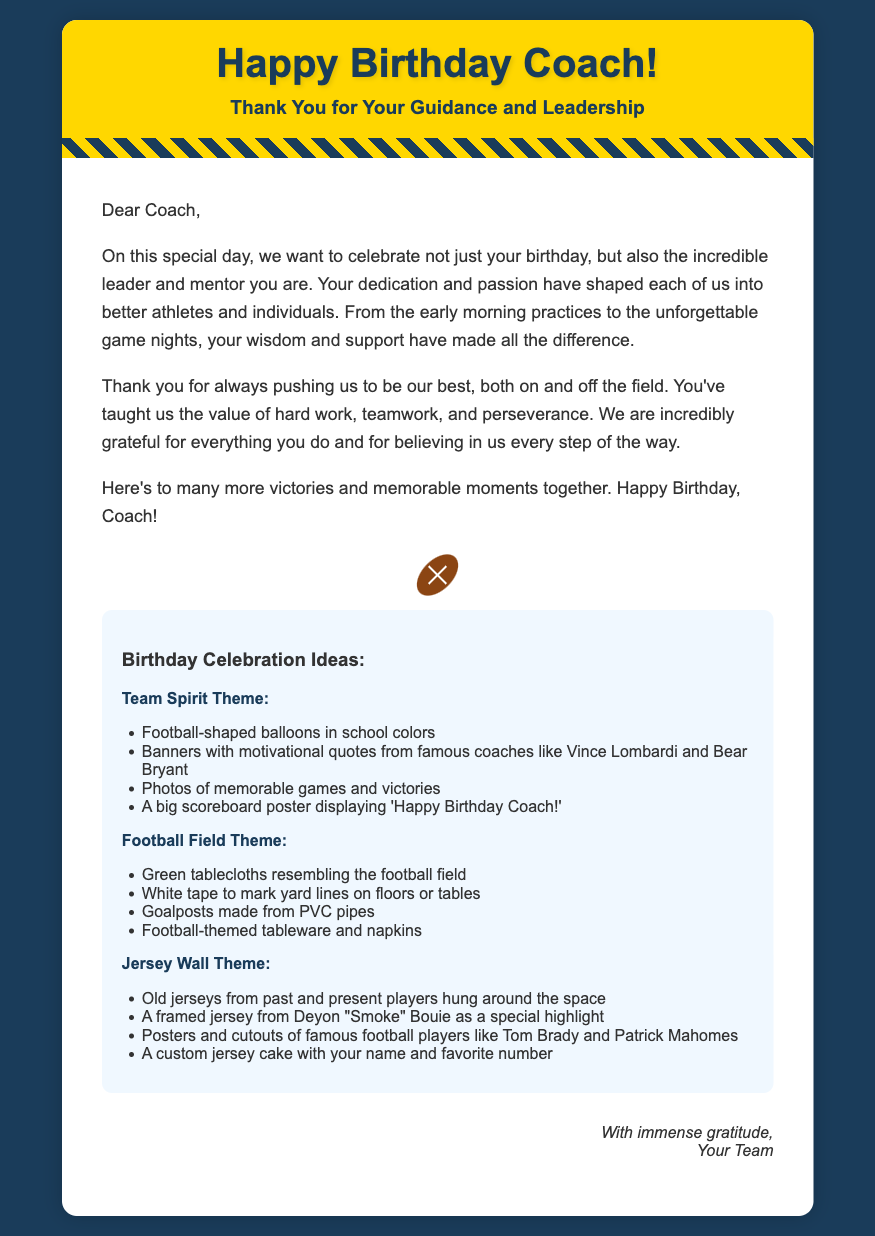What is the occasion celebrated in the card? The card celebrates the coach's birthday as indicated by the title "Happy Birthday Coach!"
Answer: birthday Who is the card addressed to? The card is addressed to the coach, as mentioned in the greeting, "Dear Coach,"
Answer: Coach What color is the header background? The header background color is gold, specifically noted as "#ffd700".
Answer: gold Which famous coaches are quoted in the decorations? The decorations mention famous coaches Vince Lombardi and Bear Bryant.
Answer: Vince Lombardi and Bear Bryant What is one item suggested for the Team Spirit Theme? The document mentions "Football-shaped balloons in school colors" as a decoration idea.
Answer: Football-shaped balloons How many themes are suggested for the birthday celebration? There are three themes discussed for the celebration in the document.
Answer: three What is a special highlight mentioned in the Jersey Wall Theme? A framed jersey from Deyon "Smoke" Bouie is highlighted in the Jersey Wall Theme.
Answer: Deyon "Smoke" Bouie In which section does the farewell message appear? The farewell message appears in the closing section at the bottom of the card.
Answer: closing 